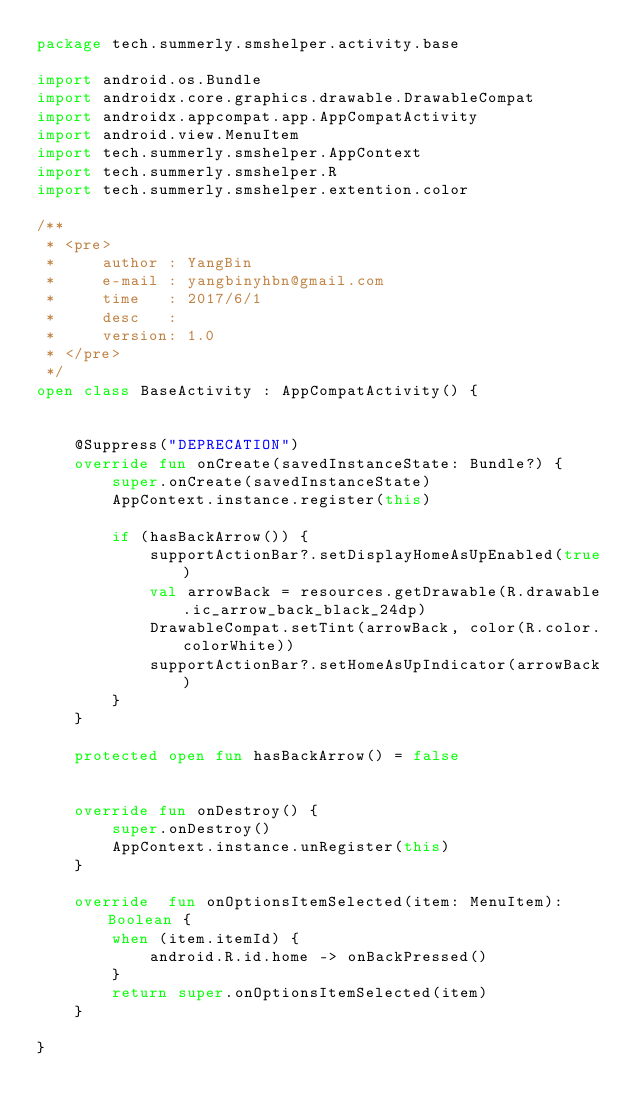<code> <loc_0><loc_0><loc_500><loc_500><_Kotlin_>package tech.summerly.smshelper.activity.base

import android.os.Bundle
import androidx.core.graphics.drawable.DrawableCompat
import androidx.appcompat.app.AppCompatActivity
import android.view.MenuItem
import tech.summerly.smshelper.AppContext
import tech.summerly.smshelper.R
import tech.summerly.smshelper.extention.color

/**
 * <pre>
 *     author : YangBin
 *     e-mail : yangbinyhbn@gmail.com
 *     time   : 2017/6/1
 *     desc   :
 *     version: 1.0
 * </pre>
 */
open class BaseActivity : AppCompatActivity() {


    @Suppress("DEPRECATION")
    override fun onCreate(savedInstanceState: Bundle?) {
        super.onCreate(savedInstanceState)
        AppContext.instance.register(this)

        if (hasBackArrow()) {
            supportActionBar?.setDisplayHomeAsUpEnabled(true)
            val arrowBack = resources.getDrawable(R.drawable.ic_arrow_back_black_24dp)
            DrawableCompat.setTint(arrowBack, color(R.color.colorWhite))
            supportActionBar?.setHomeAsUpIndicator(arrowBack)
        }
    }

    protected open fun hasBackArrow() = false


    override fun onDestroy() {
        super.onDestroy()
        AppContext.instance.unRegister(this)
    }

    override  fun onOptionsItemSelected(item: MenuItem): Boolean {
        when (item.itemId) {
            android.R.id.home -> onBackPressed()
        }
        return super.onOptionsItemSelected(item)
    }

}</code> 